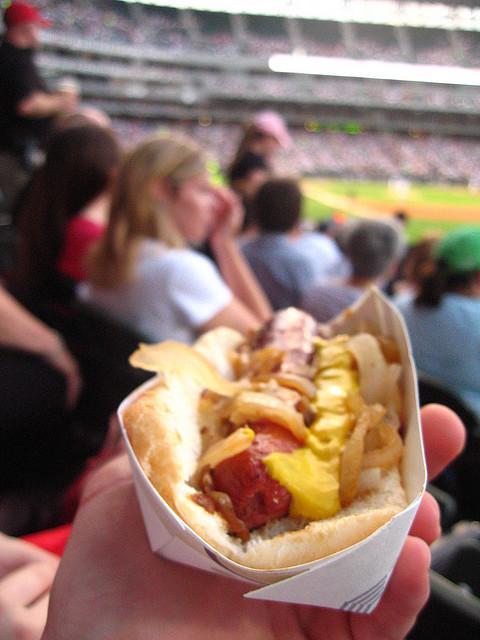How many people can you see?
Give a very brief answer. 10. 